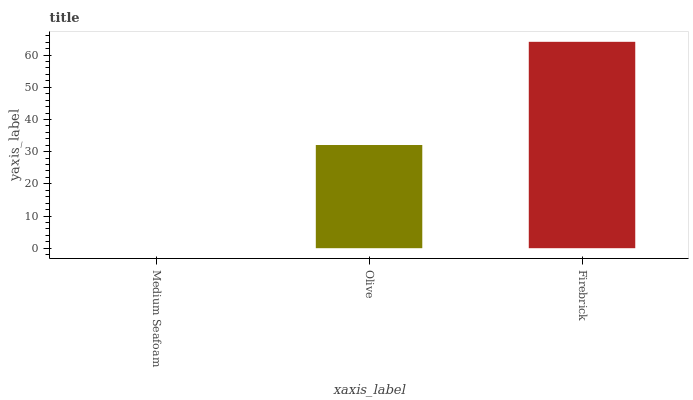Is Olive the minimum?
Answer yes or no. No. Is Olive the maximum?
Answer yes or no. No. Is Olive greater than Medium Seafoam?
Answer yes or no. Yes. Is Medium Seafoam less than Olive?
Answer yes or no. Yes. Is Medium Seafoam greater than Olive?
Answer yes or no. No. Is Olive less than Medium Seafoam?
Answer yes or no. No. Is Olive the high median?
Answer yes or no. Yes. Is Olive the low median?
Answer yes or no. Yes. Is Medium Seafoam the high median?
Answer yes or no. No. Is Firebrick the low median?
Answer yes or no. No. 